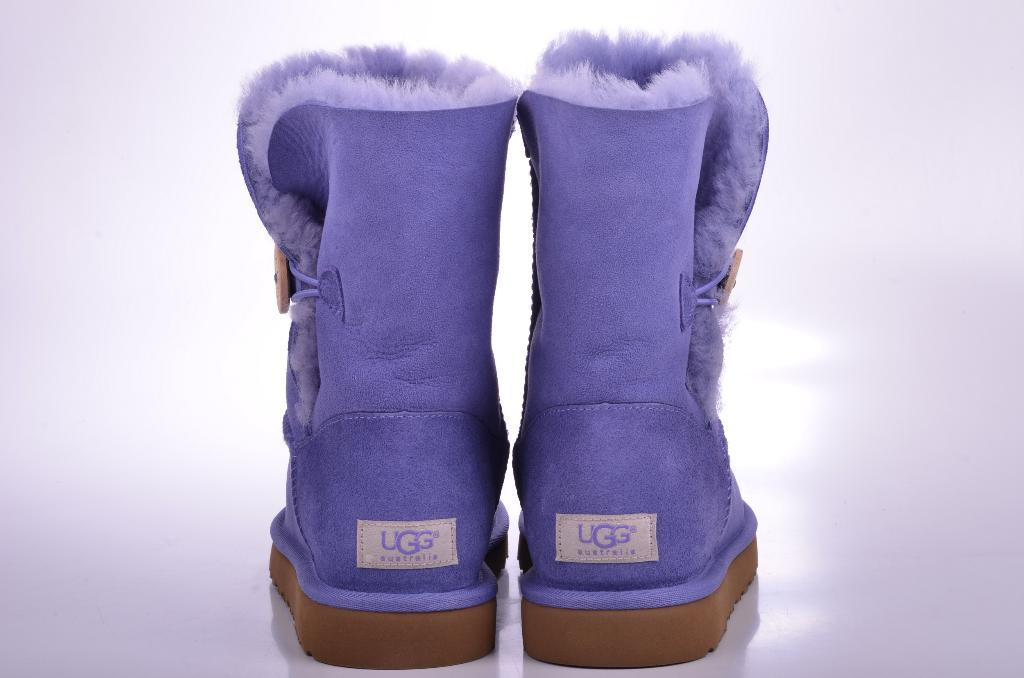What type of objects are in the image? There are footwear in the image. What colors can be seen on the footwear? The footwear has purple and brown colors. What is the color of the surface the footwear is placed on? The footwear is on a white surface. What type of silk material is used to make the building in the image? There is no building present in the image, and silk is not mentioned as a material for any object. 